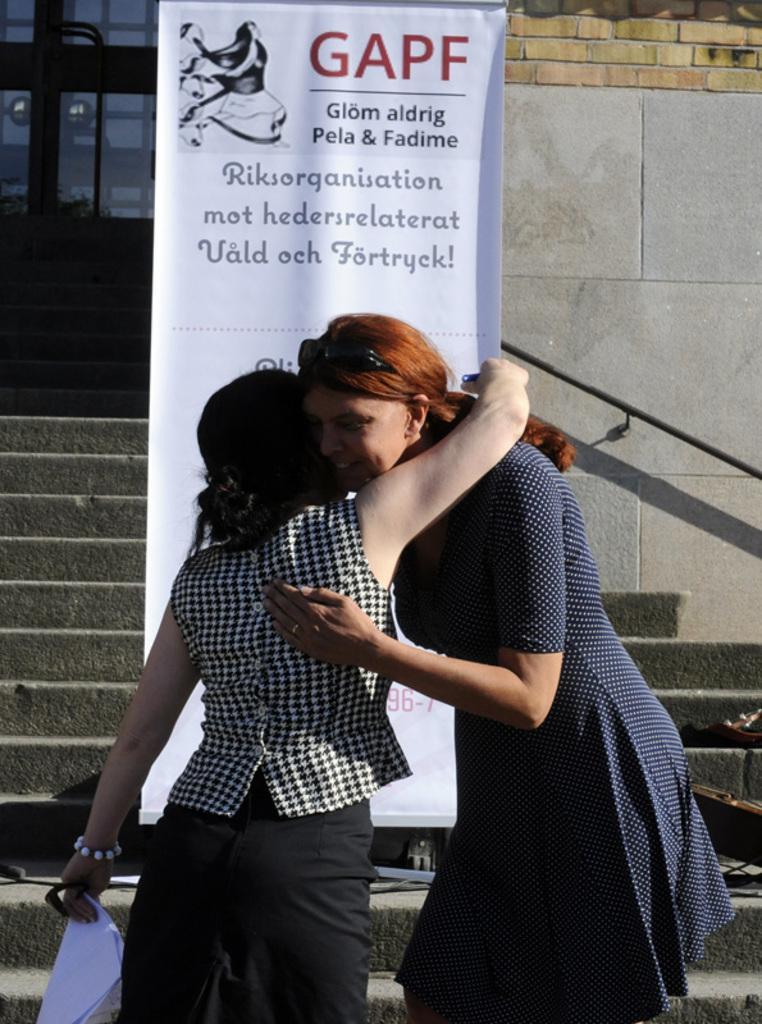Please provide a concise description of this image. In this image two women are hugging each other. They are standing. Behind them there is a banner on the staircase. Background there is a wall having a door. 